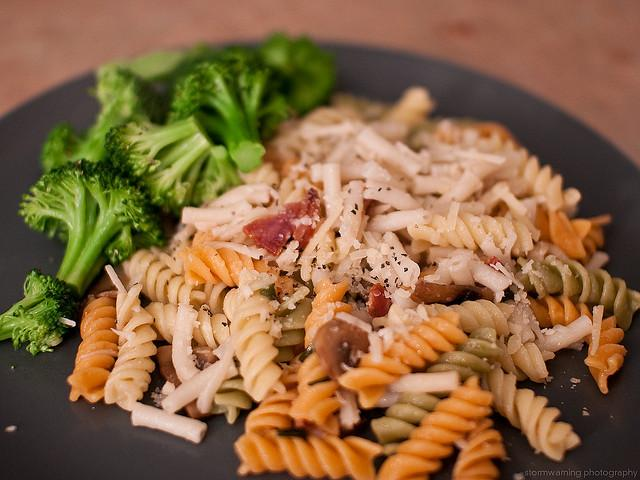What is next to the pasta? broccoli 